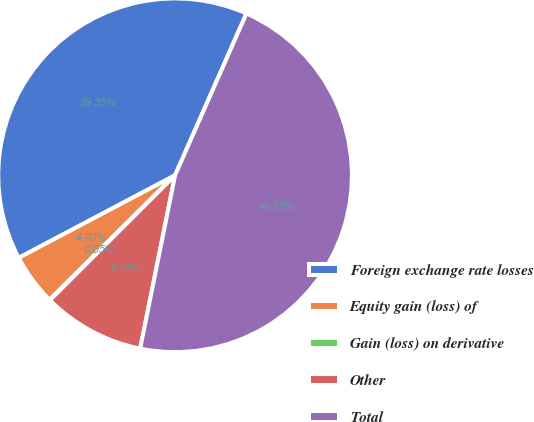<chart> <loc_0><loc_0><loc_500><loc_500><pie_chart><fcel>Foreign exchange rate losses<fcel>Equity gain (loss) of<fcel>Gain (loss) on derivative<fcel>Other<fcel>Total<nl><fcel>39.35%<fcel>4.7%<fcel>0.05%<fcel>9.35%<fcel>46.55%<nl></chart> 